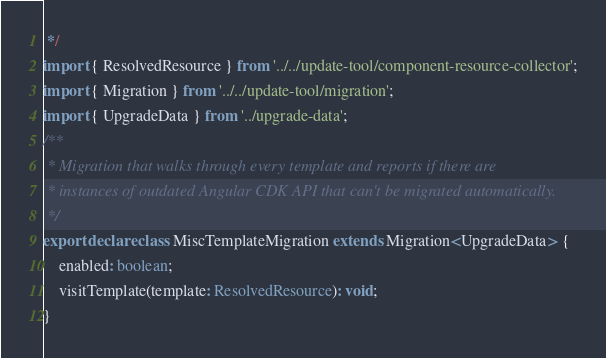Convert code to text. <code><loc_0><loc_0><loc_500><loc_500><_TypeScript_> */
import { ResolvedResource } from '../../update-tool/component-resource-collector';
import { Migration } from '../../update-tool/migration';
import { UpgradeData } from '../upgrade-data';
/**
 * Migration that walks through every template and reports if there are
 * instances of outdated Angular CDK API that can't be migrated automatically.
 */
export declare class MiscTemplateMigration extends Migration<UpgradeData> {
    enabled: boolean;
    visitTemplate(template: ResolvedResource): void;
}
</code> 